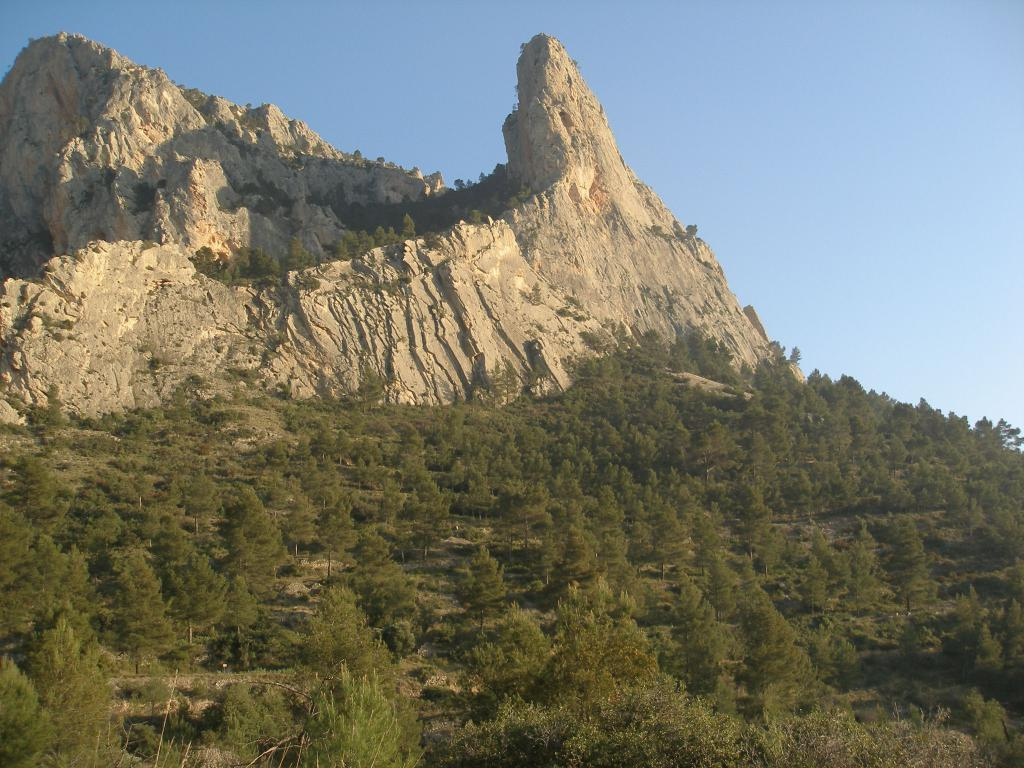What can be seen in the background of the image? The sky, hills, and plants are visible in the background of the image. What type of terrain is present at the bottom portion of the image? The land at the bottom portion of the image is covered with plants. What type of waves can be seen crashing on the shore in the image? There is no shore or waves present in the image; it features a landscape with hills and plants. 